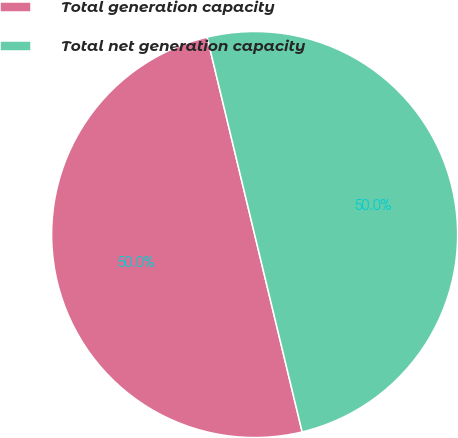<chart> <loc_0><loc_0><loc_500><loc_500><pie_chart><fcel>Total generation capacity<fcel>Total net generation capacity<nl><fcel>50.0%<fcel>50.0%<nl></chart> 